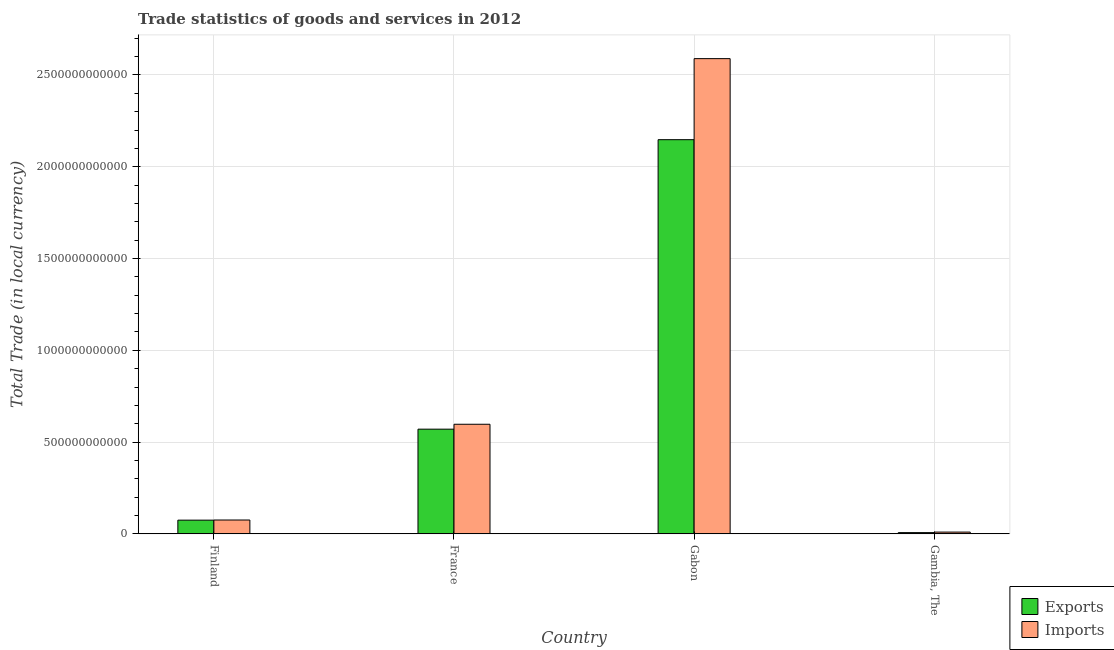How many different coloured bars are there?
Provide a short and direct response. 2. How many groups of bars are there?
Your response must be concise. 4. Are the number of bars per tick equal to the number of legend labels?
Offer a very short reply. Yes. How many bars are there on the 1st tick from the left?
Make the answer very short. 2. How many bars are there on the 1st tick from the right?
Offer a very short reply. 2. What is the label of the 3rd group of bars from the left?
Your answer should be very brief. Gabon. What is the imports of goods and services in Finland?
Ensure brevity in your answer.  7.54e+1. Across all countries, what is the maximum imports of goods and services?
Give a very brief answer. 2.59e+12. Across all countries, what is the minimum imports of goods and services?
Give a very brief answer. 9.68e+09. In which country was the imports of goods and services maximum?
Keep it short and to the point. Gabon. In which country was the export of goods and services minimum?
Ensure brevity in your answer.  Gambia, The. What is the total export of goods and services in the graph?
Provide a short and direct response. 2.80e+12. What is the difference between the imports of goods and services in Gabon and that in Gambia, The?
Ensure brevity in your answer.  2.58e+12. What is the difference between the imports of goods and services in Gambia, The and the export of goods and services in France?
Provide a short and direct response. -5.61e+11. What is the average imports of goods and services per country?
Your response must be concise. 8.18e+11. What is the difference between the imports of goods and services and export of goods and services in Gambia, The?
Offer a very short reply. 2.94e+09. In how many countries, is the export of goods and services greater than 2100000000000 LCU?
Offer a very short reply. 1. What is the ratio of the export of goods and services in France to that in Gabon?
Offer a terse response. 0.27. Is the difference between the imports of goods and services in Gabon and Gambia, The greater than the difference between the export of goods and services in Gabon and Gambia, The?
Ensure brevity in your answer.  Yes. What is the difference between the highest and the second highest imports of goods and services?
Give a very brief answer. 1.99e+12. What is the difference between the highest and the lowest export of goods and services?
Provide a succinct answer. 2.14e+12. What does the 2nd bar from the left in Gambia, The represents?
Ensure brevity in your answer.  Imports. What does the 2nd bar from the right in Finland represents?
Provide a short and direct response. Exports. How many bars are there?
Your answer should be compact. 8. What is the difference between two consecutive major ticks on the Y-axis?
Your response must be concise. 5.00e+11. Are the values on the major ticks of Y-axis written in scientific E-notation?
Make the answer very short. No. Does the graph contain any zero values?
Your answer should be compact. No. How are the legend labels stacked?
Offer a very short reply. Vertical. What is the title of the graph?
Your answer should be very brief. Trade statistics of goods and services in 2012. What is the label or title of the Y-axis?
Offer a very short reply. Total Trade (in local currency). What is the Total Trade (in local currency) of Exports in Finland?
Provide a short and direct response. 7.47e+1. What is the Total Trade (in local currency) of Imports in Finland?
Offer a terse response. 7.54e+1. What is the Total Trade (in local currency) in Exports in France?
Offer a terse response. 5.70e+11. What is the Total Trade (in local currency) in Imports in France?
Ensure brevity in your answer.  5.97e+11. What is the Total Trade (in local currency) of Exports in Gabon?
Offer a terse response. 2.15e+12. What is the Total Trade (in local currency) in Imports in Gabon?
Make the answer very short. 2.59e+12. What is the Total Trade (in local currency) of Exports in Gambia, The?
Offer a very short reply. 6.75e+09. What is the Total Trade (in local currency) of Imports in Gambia, The?
Provide a short and direct response. 9.68e+09. Across all countries, what is the maximum Total Trade (in local currency) in Exports?
Your answer should be compact. 2.15e+12. Across all countries, what is the maximum Total Trade (in local currency) in Imports?
Provide a succinct answer. 2.59e+12. Across all countries, what is the minimum Total Trade (in local currency) in Exports?
Ensure brevity in your answer.  6.75e+09. Across all countries, what is the minimum Total Trade (in local currency) of Imports?
Your answer should be compact. 9.68e+09. What is the total Total Trade (in local currency) in Exports in the graph?
Offer a very short reply. 2.80e+12. What is the total Total Trade (in local currency) of Imports in the graph?
Your response must be concise. 3.27e+12. What is the difference between the Total Trade (in local currency) in Exports in Finland and that in France?
Your answer should be very brief. -4.96e+11. What is the difference between the Total Trade (in local currency) of Imports in Finland and that in France?
Your answer should be very brief. -5.22e+11. What is the difference between the Total Trade (in local currency) in Exports in Finland and that in Gabon?
Your response must be concise. -2.07e+12. What is the difference between the Total Trade (in local currency) in Imports in Finland and that in Gabon?
Keep it short and to the point. -2.51e+12. What is the difference between the Total Trade (in local currency) in Exports in Finland and that in Gambia, The?
Offer a very short reply. 6.80e+1. What is the difference between the Total Trade (in local currency) of Imports in Finland and that in Gambia, The?
Keep it short and to the point. 6.58e+1. What is the difference between the Total Trade (in local currency) in Exports in France and that in Gabon?
Your answer should be compact. -1.58e+12. What is the difference between the Total Trade (in local currency) in Imports in France and that in Gabon?
Your response must be concise. -1.99e+12. What is the difference between the Total Trade (in local currency) in Exports in France and that in Gambia, The?
Your response must be concise. 5.64e+11. What is the difference between the Total Trade (in local currency) of Imports in France and that in Gambia, The?
Your response must be concise. 5.87e+11. What is the difference between the Total Trade (in local currency) in Exports in Gabon and that in Gambia, The?
Offer a very short reply. 2.14e+12. What is the difference between the Total Trade (in local currency) in Imports in Gabon and that in Gambia, The?
Offer a very short reply. 2.58e+12. What is the difference between the Total Trade (in local currency) of Exports in Finland and the Total Trade (in local currency) of Imports in France?
Offer a terse response. -5.22e+11. What is the difference between the Total Trade (in local currency) in Exports in Finland and the Total Trade (in local currency) in Imports in Gabon?
Make the answer very short. -2.51e+12. What is the difference between the Total Trade (in local currency) in Exports in Finland and the Total Trade (in local currency) in Imports in Gambia, The?
Offer a very short reply. 6.50e+1. What is the difference between the Total Trade (in local currency) of Exports in France and the Total Trade (in local currency) of Imports in Gabon?
Ensure brevity in your answer.  -2.02e+12. What is the difference between the Total Trade (in local currency) of Exports in France and the Total Trade (in local currency) of Imports in Gambia, The?
Your answer should be compact. 5.61e+11. What is the difference between the Total Trade (in local currency) in Exports in Gabon and the Total Trade (in local currency) in Imports in Gambia, The?
Make the answer very short. 2.14e+12. What is the average Total Trade (in local currency) in Exports per country?
Your response must be concise. 7.00e+11. What is the average Total Trade (in local currency) in Imports per country?
Your answer should be compact. 8.18e+11. What is the difference between the Total Trade (in local currency) in Exports and Total Trade (in local currency) in Imports in Finland?
Give a very brief answer. -7.15e+08. What is the difference between the Total Trade (in local currency) of Exports and Total Trade (in local currency) of Imports in France?
Provide a short and direct response. -2.67e+1. What is the difference between the Total Trade (in local currency) of Exports and Total Trade (in local currency) of Imports in Gabon?
Offer a terse response. -4.41e+11. What is the difference between the Total Trade (in local currency) of Exports and Total Trade (in local currency) of Imports in Gambia, The?
Provide a succinct answer. -2.94e+09. What is the ratio of the Total Trade (in local currency) of Exports in Finland to that in France?
Provide a short and direct response. 0.13. What is the ratio of the Total Trade (in local currency) in Imports in Finland to that in France?
Keep it short and to the point. 0.13. What is the ratio of the Total Trade (in local currency) of Exports in Finland to that in Gabon?
Provide a succinct answer. 0.03. What is the ratio of the Total Trade (in local currency) in Imports in Finland to that in Gabon?
Your answer should be compact. 0.03. What is the ratio of the Total Trade (in local currency) of Exports in Finland to that in Gambia, The?
Provide a short and direct response. 11.08. What is the ratio of the Total Trade (in local currency) of Imports in Finland to that in Gambia, The?
Provide a short and direct response. 7.79. What is the ratio of the Total Trade (in local currency) in Exports in France to that in Gabon?
Provide a succinct answer. 0.27. What is the ratio of the Total Trade (in local currency) in Imports in France to that in Gabon?
Provide a succinct answer. 0.23. What is the ratio of the Total Trade (in local currency) of Exports in France to that in Gambia, The?
Ensure brevity in your answer.  84.55. What is the ratio of the Total Trade (in local currency) in Imports in France to that in Gambia, The?
Your answer should be very brief. 61.68. What is the ratio of the Total Trade (in local currency) in Exports in Gabon to that in Gambia, The?
Give a very brief answer. 318.33. What is the ratio of the Total Trade (in local currency) in Imports in Gabon to that in Gambia, The?
Make the answer very short. 267.43. What is the difference between the highest and the second highest Total Trade (in local currency) of Exports?
Offer a very short reply. 1.58e+12. What is the difference between the highest and the second highest Total Trade (in local currency) in Imports?
Provide a succinct answer. 1.99e+12. What is the difference between the highest and the lowest Total Trade (in local currency) in Exports?
Keep it short and to the point. 2.14e+12. What is the difference between the highest and the lowest Total Trade (in local currency) in Imports?
Provide a succinct answer. 2.58e+12. 